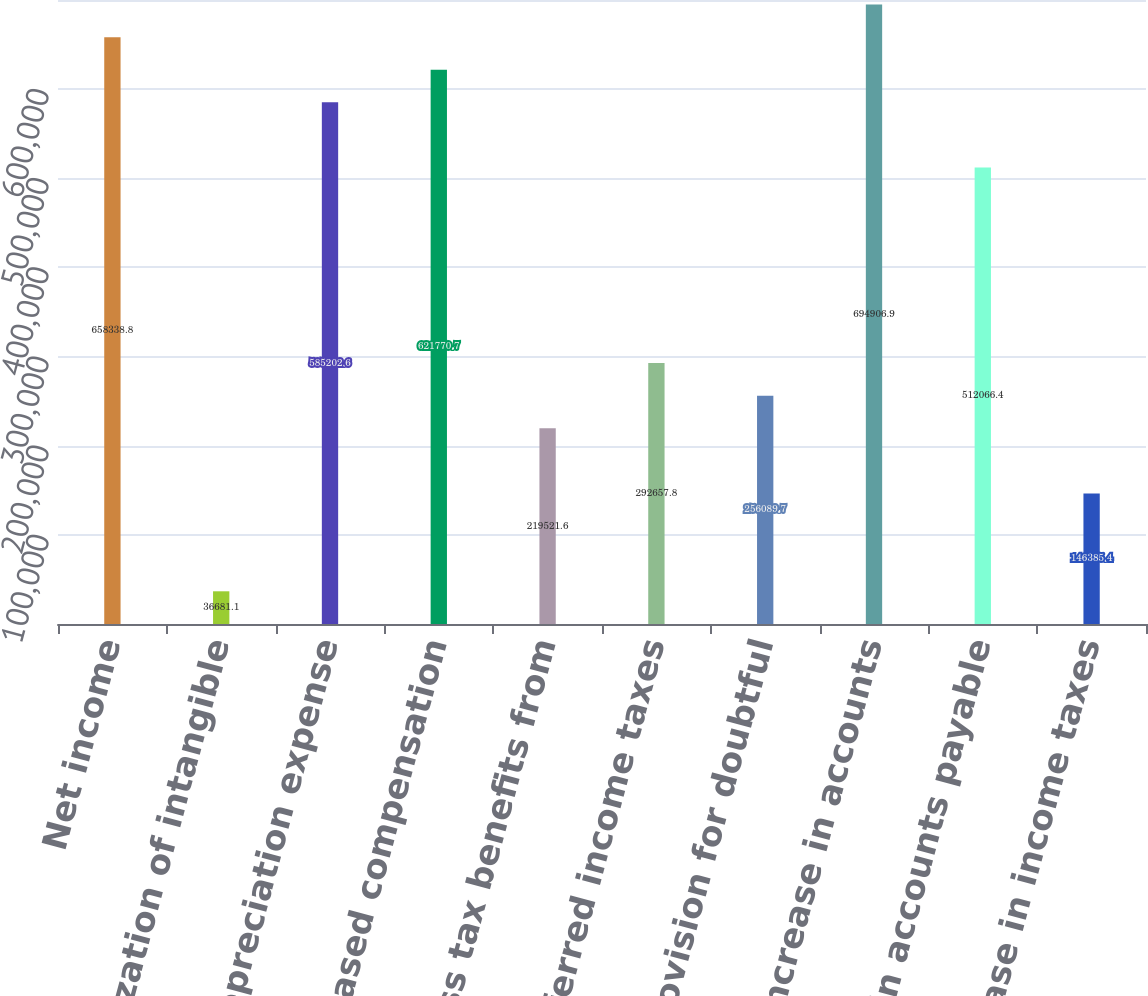<chart> <loc_0><loc_0><loc_500><loc_500><bar_chart><fcel>Net income<fcel>Amortization of intangible<fcel>Depreciation expense<fcel>Stock-based compensation<fcel>Excess tax benefits from<fcel>Deferred income taxes<fcel>Provision for doubtful<fcel>Increase in accounts<fcel>Increase in accounts payable<fcel>Increase in income taxes<nl><fcel>658339<fcel>36681.1<fcel>585203<fcel>621771<fcel>219522<fcel>292658<fcel>256090<fcel>694907<fcel>512066<fcel>146385<nl></chart> 